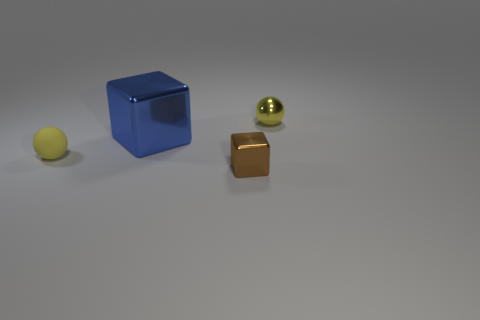Add 1 tiny gray blocks. How many objects exist? 5 Subtract 0 cyan blocks. How many objects are left? 4 Subtract all small shiny cubes. Subtract all gray objects. How many objects are left? 3 Add 4 large blue shiny things. How many large blue shiny things are left? 5 Add 2 brown objects. How many brown objects exist? 3 